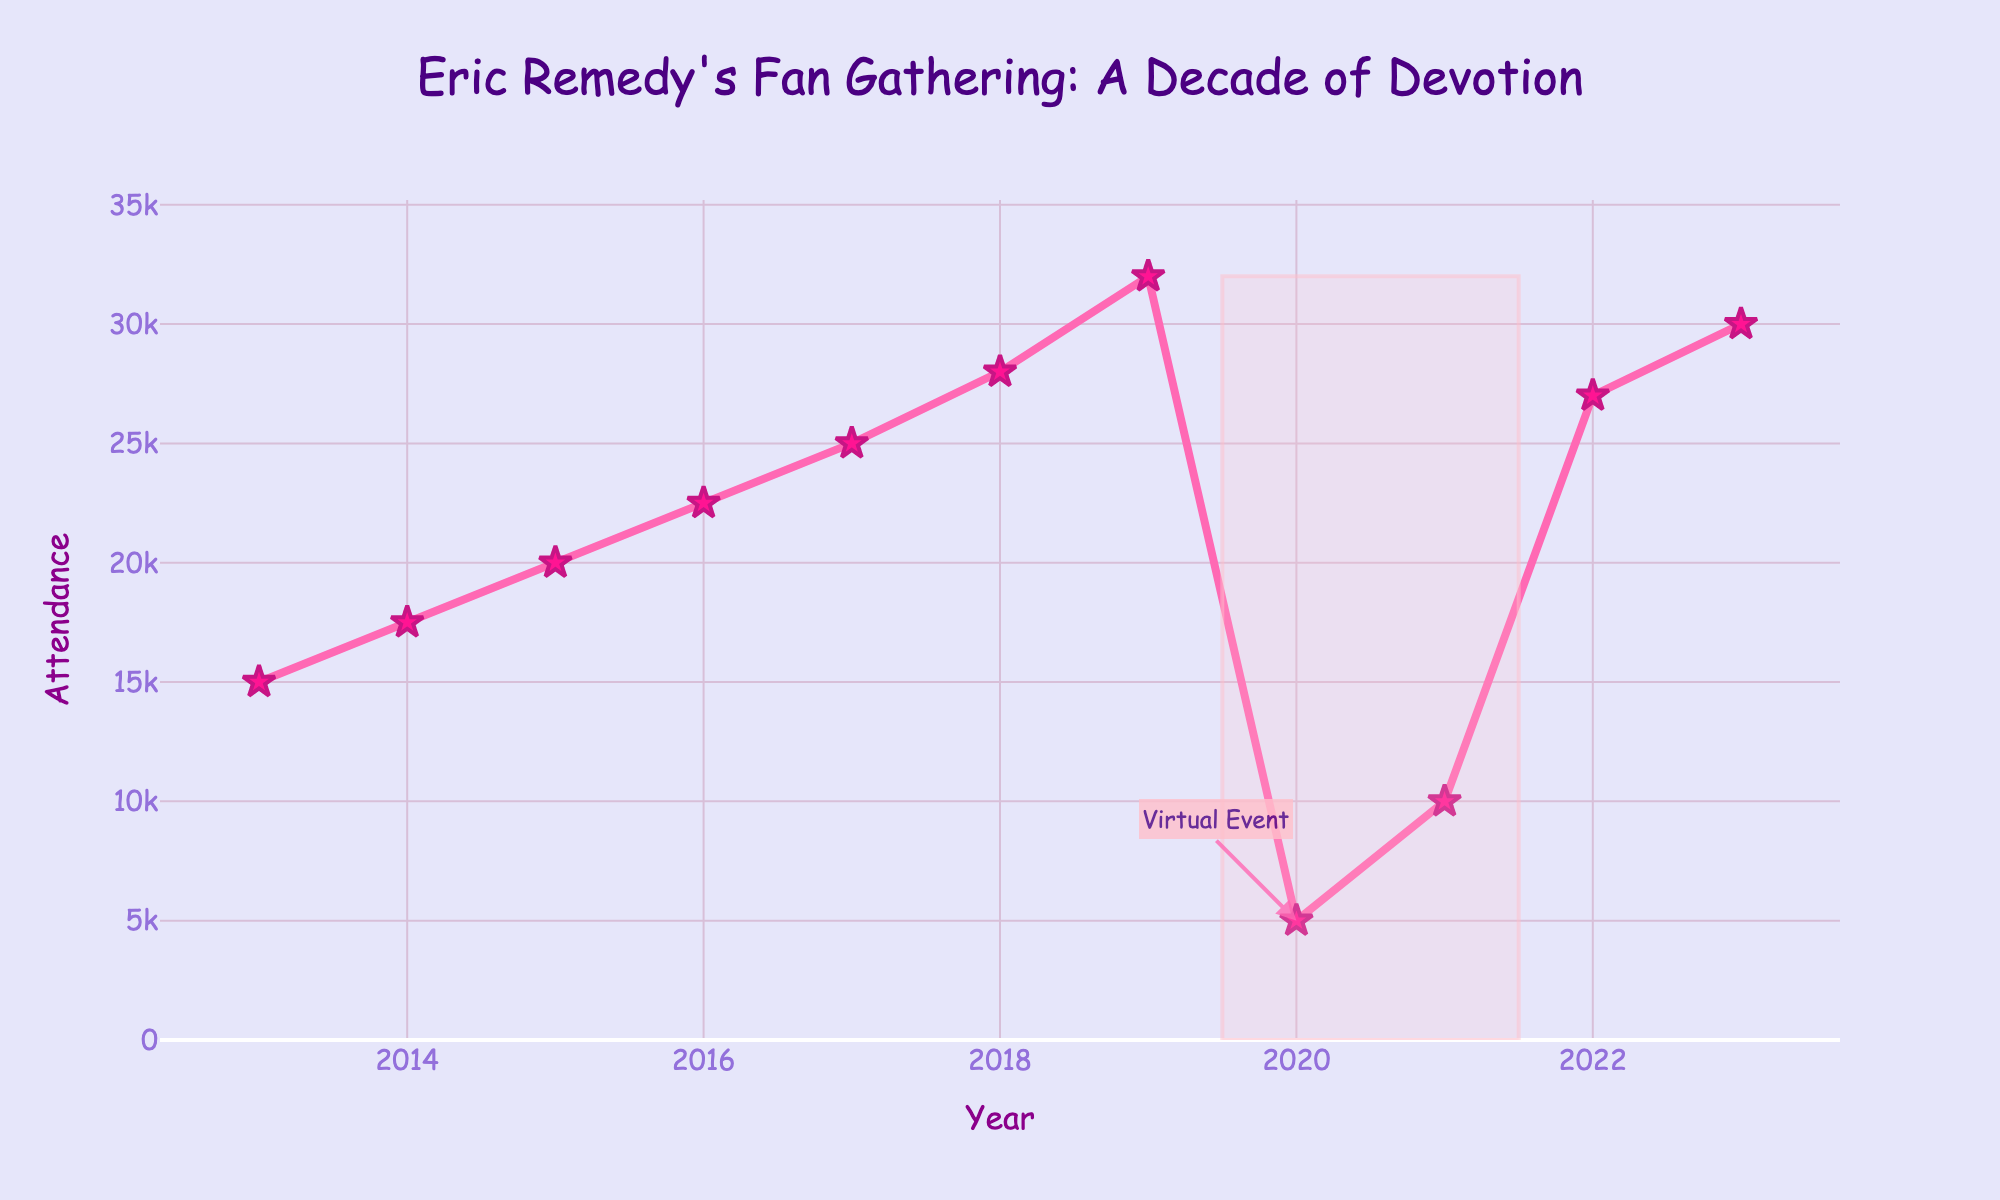What's the attendance in 2020? The year 2020 is marked specifically on the plot. Look for the attendance value at that point.
Answer: 5000 How does the festival attendance in 2022 compare to 2013? Find the attendance values for 2022 and 2013 from the plot. Compare the two values to see which is higher.
Answer: 2022 had higher attendance What is the overall trend in festival attendance from 2013 to 2023? Observe the general direction of the line chart from 2013 to 2023, noting any increases or decreases.
Answer: Upward trend What is the average attendance from 2016 to 2019? Sum the attendance values from 2016 to 2019 and divide by the number of years (22500 + 25000 + 28000 + 32000) / 4.
Answer: 26875 Which year had the highest attendance? Look for the highest point on the line chart and check the corresponding year on the x-axis.
Answer: 2019 What can you infer from the shape highlighted in 2019-2021? The shaded region indicates an unusual dip in attendance. Note the annotation for further context.
Answer: Attendance dropped due to a virtual event By how much did the attendance increase from 2015 to 2019? Subtract the attendance in 2015 from the attendance in 2019 (32000 - 20000).
Answer: 12000 What was the difference in attendance between 2018 and 2021? Subtract the attendance in 2021 from the attendance in 2018 (28000 - 10000).
Answer: 18000 What is the median attendance value for all the years shown? Order the attendance values from smallest to largest and find the middle value. If even number of values, take the average of the two middle values.
Answer: 22500 How did the attendance change from 2020 to 2021? Compare the attendance values for 2020 and 2021. Note the increase or decrease (10000 - 5000).
Answer: Increased by 5000 